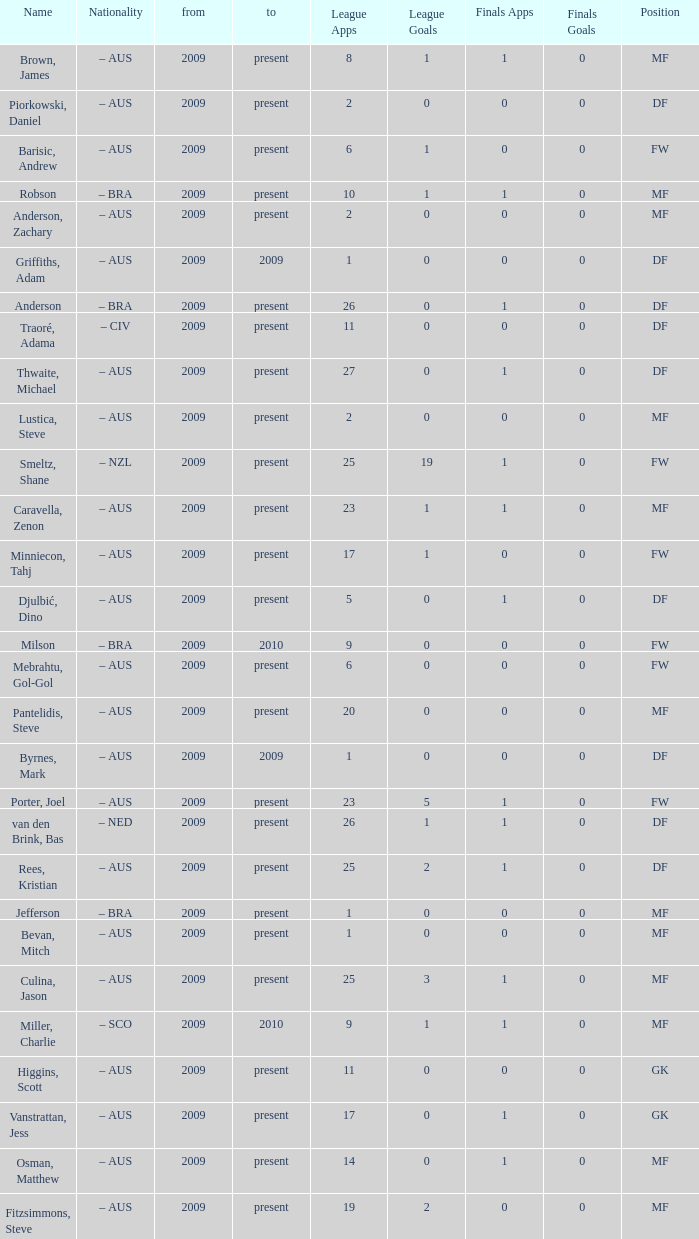Parse the full table. {'header': ['Name', 'Nationality', 'from', 'to', 'League Apps', 'League Goals', 'Finals Apps', 'Finals Goals', 'Position'], 'rows': [['Brown, James', '– AUS', '2009', 'present', '8', '1', '1', '0', 'MF'], ['Piorkowski, Daniel', '– AUS', '2009', 'present', '2', '0', '0', '0', 'DF'], ['Barisic, Andrew', '– AUS', '2009', 'present', '6', '1', '0', '0', 'FW'], ['Robson', '– BRA', '2009', 'present', '10', '1', '1', '0', 'MF'], ['Anderson, Zachary', '– AUS', '2009', 'present', '2', '0', '0', '0', 'MF'], ['Griffiths, Adam', '– AUS', '2009', '2009', '1', '0', '0', '0', 'DF'], ['Anderson', '– BRA', '2009', 'present', '26', '0', '1', '0', 'DF'], ['Traoré, Adama', '– CIV', '2009', 'present', '11', '0', '0', '0', 'DF'], ['Thwaite, Michael', '– AUS', '2009', 'present', '27', '0', '1', '0', 'DF'], ['Lustica, Steve', '– AUS', '2009', 'present', '2', '0', '0', '0', 'MF'], ['Smeltz, Shane', '– NZL', '2009', 'present', '25', '19', '1', '0', 'FW'], ['Caravella, Zenon', '– AUS', '2009', 'present', '23', '1', '1', '0', 'MF'], ['Minniecon, Tahj', '– AUS', '2009', 'present', '17', '1', '0', '0', 'FW'], ['Djulbić, Dino', '– AUS', '2009', 'present', '5', '0', '1', '0', 'DF'], ['Milson', '– BRA', '2009', '2010', '9', '0', '0', '0', 'FW'], ['Mebrahtu, Gol-Gol', '– AUS', '2009', 'present', '6', '0', '0', '0', 'FW'], ['Pantelidis, Steve', '– AUS', '2009', 'present', '20', '0', '0', '0', 'MF'], ['Byrnes, Mark', '– AUS', '2009', '2009', '1', '0', '0', '0', 'DF'], ['Porter, Joel', '– AUS', '2009', 'present', '23', '5', '1', '0', 'FW'], ['van den Brink, Bas', '– NED', '2009', 'present', '26', '1', '1', '0', 'DF'], ['Rees, Kristian', '– AUS', '2009', 'present', '25', '2', '1', '0', 'DF'], ['Jefferson', '– BRA', '2009', 'present', '1', '0', '0', '0', 'MF'], ['Bevan, Mitch', '– AUS', '2009', 'present', '1', '0', '0', '0', 'MF'], ['Culina, Jason', '– AUS', '2009', 'present', '25', '3', '1', '0', 'MF'], ['Miller, Charlie', '– SCO', '2009', '2010', '9', '1', '1', '0', 'MF'], ['Higgins, Scott', '– AUS', '2009', 'present', '11', '0', '0', '0', 'GK'], ['Vanstrattan, Jess', '– AUS', '2009', 'present', '17', '0', '1', '0', 'GK'], ['Osman, Matthew', '– AUS', '2009', 'present', '14', '0', '1', '0', 'MF'], ['Fitzsimmons, Steve', '– AUS', '2009', 'present', '19', '2', '0', '0', 'MF']]} Name the mosst finals apps 1.0. 